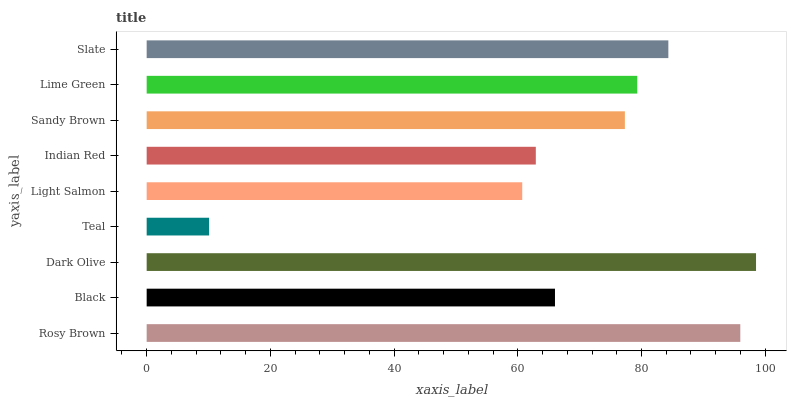Is Teal the minimum?
Answer yes or no. Yes. Is Dark Olive the maximum?
Answer yes or no. Yes. Is Black the minimum?
Answer yes or no. No. Is Black the maximum?
Answer yes or no. No. Is Rosy Brown greater than Black?
Answer yes or no. Yes. Is Black less than Rosy Brown?
Answer yes or no. Yes. Is Black greater than Rosy Brown?
Answer yes or no. No. Is Rosy Brown less than Black?
Answer yes or no. No. Is Sandy Brown the high median?
Answer yes or no. Yes. Is Sandy Brown the low median?
Answer yes or no. Yes. Is Slate the high median?
Answer yes or no. No. Is Dark Olive the low median?
Answer yes or no. No. 